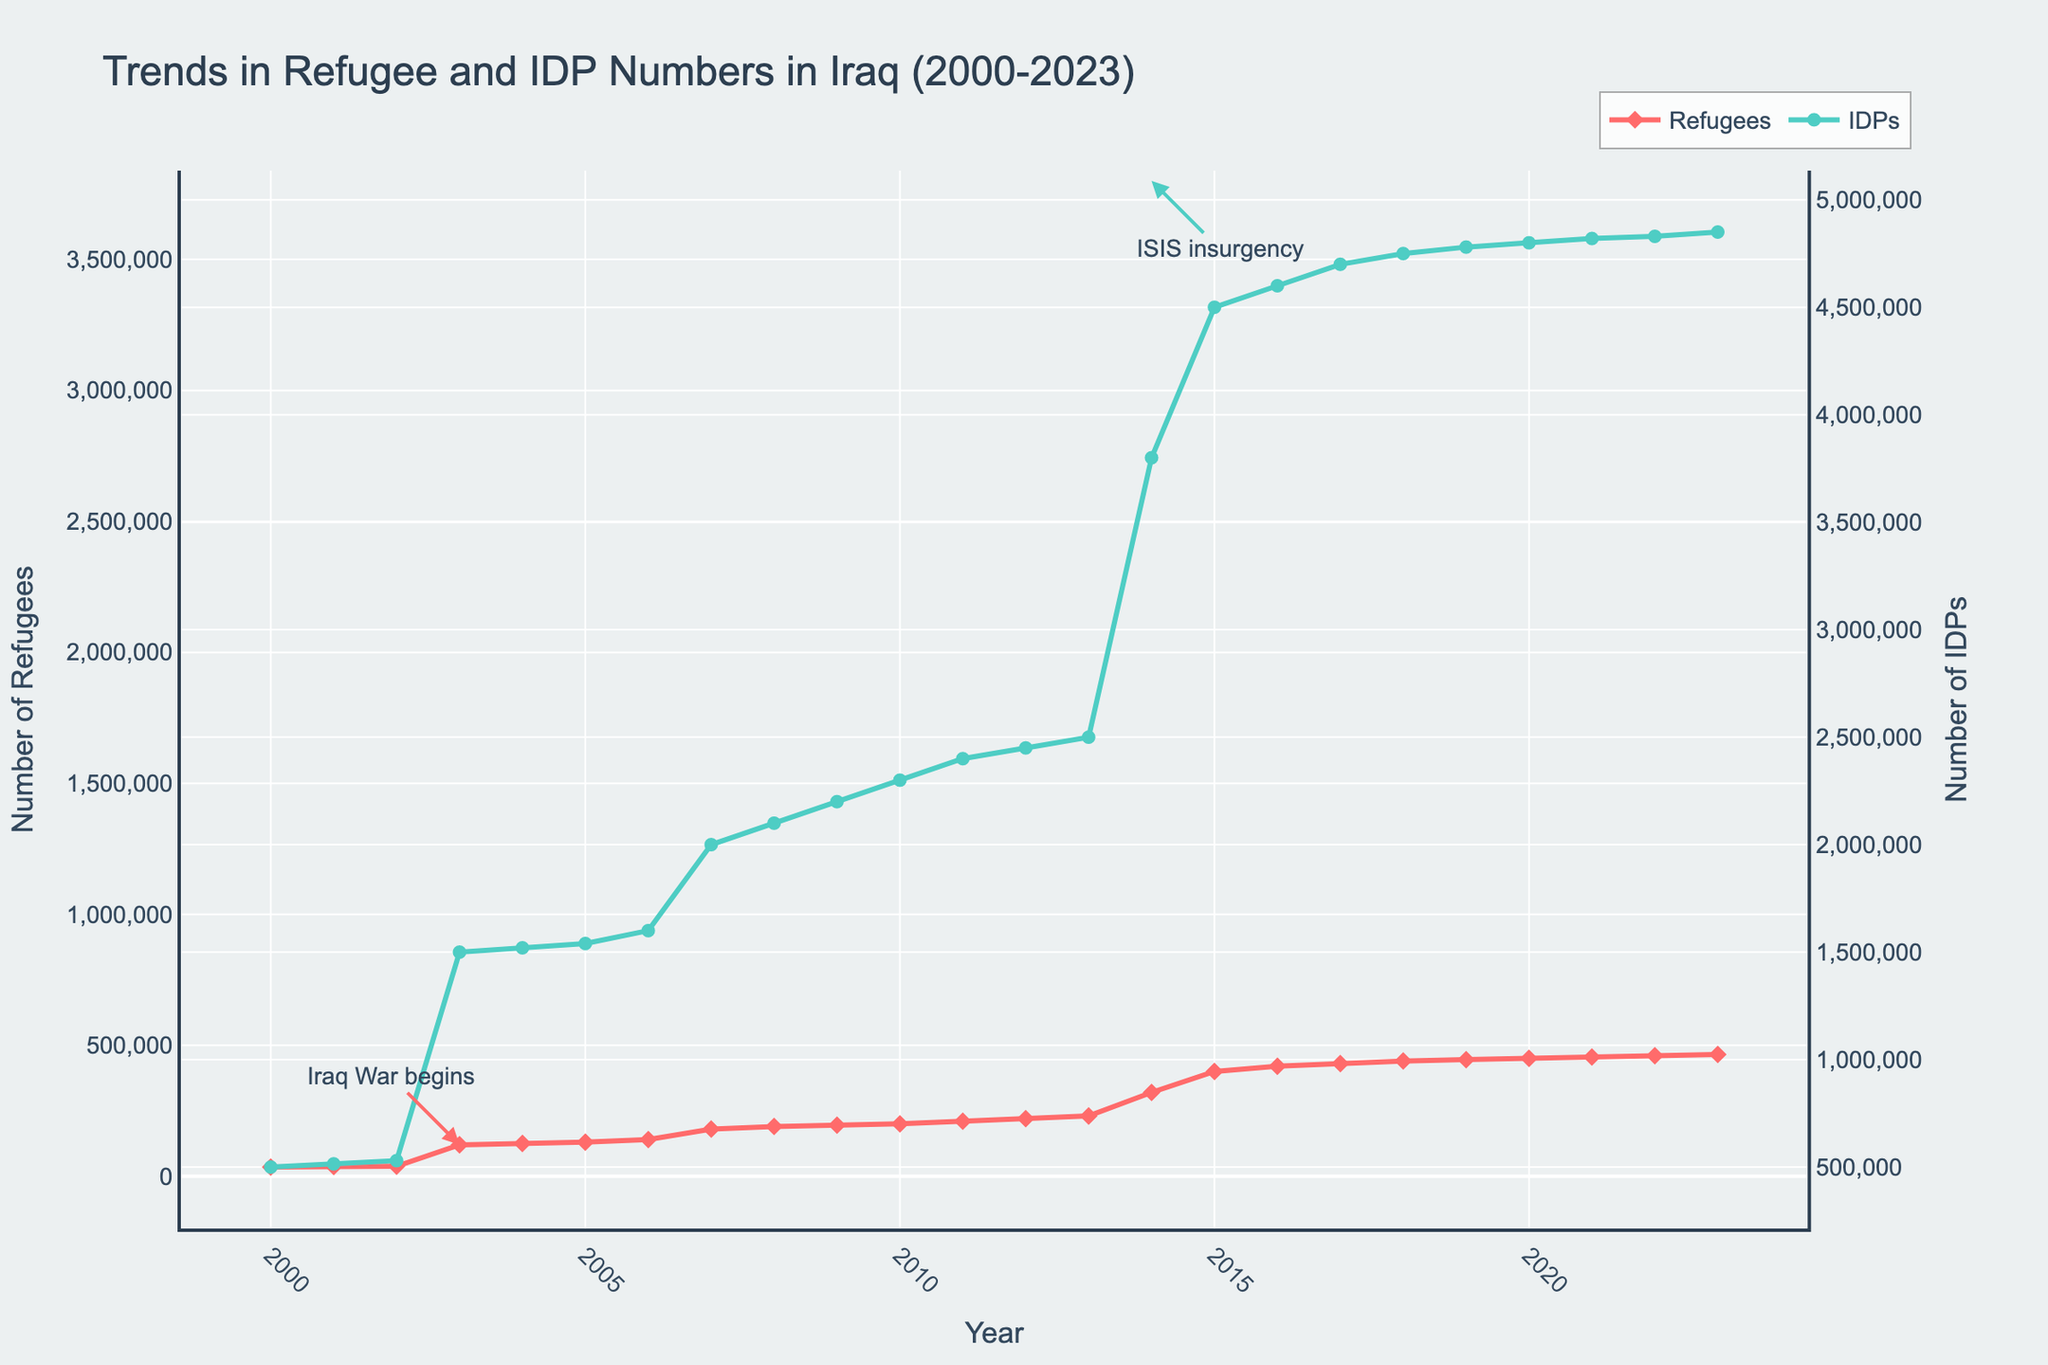What are the trends in the numbers of refugees and IDPs in Iraq from 2000 to 2023? The plot shows two separate trends, one for refugees and another for internally displaced persons (IDPs). Refugee numbers slowly increased from 2000 to 2012, then rose sharply in 2014 and continued to increase steadily until 2023. IDP numbers grew steadily from 2000, spiked significantly in 2003 and again in 2014, reaching the highest value by 2023.
Answer: Both trends increased, with sharp spikes in 2003 and 2014 for IDPs What significant events are annotated on the figure, and when did they occur? The figure has two annotations marking significant events: "Iraq War begins" in 2003 and "ISIS insurgency" in 2014.
Answer: Iraq War in 2003 and ISIS insurgency in 2014 How did the number of refugees change in 2003? In 2003, the number of refugees increased significantly from the previous year (from 38,000 in 2002 to 120,000 in 2003).
Answer: Increased significantly Which year shows the highest number of IDPs on the plot? The number of IDPs is highest in 2023, as indicated by the right vertical axis.
Answer: 2023 By how much did the number of IDPs increase from 2013 to 2014? The number of IDPs in 2013 was 2,500,000 and in 2014 was 3,800,000, so the increase is 3,800,000 - 2,500,000 = 1,300,000.
Answer: 1,300,000 Compare the slope of the refugee number trend before and after 2014. Which period shows a steeper increase? Before 2014, the increase in refugee numbers is gradual. After 2014, the slope is steeper, indicating a faster rate of increase in refugee numbers.
Answer: After 2014 What are the respective colors used to represent the data for refugees and IDPs? Refugees are represented by a red line with diamond markers, and IDPs are represented by a green line with circle markers.
Answer: Red for refugees, green for IDPs What was the approximate number of refugees right before the ISIS insurgency in 2014? The number of refugees in 2013, right before the ISIS insurgency in 2014, was approximately 230,000.
Answer: 230,000 Does the trend of IDPs show any major spikes? If so, in which years do they occur? Yes, the trend of IDPs shows major spikes in 2003 and 2014.
Answer: 2003 and 2014 